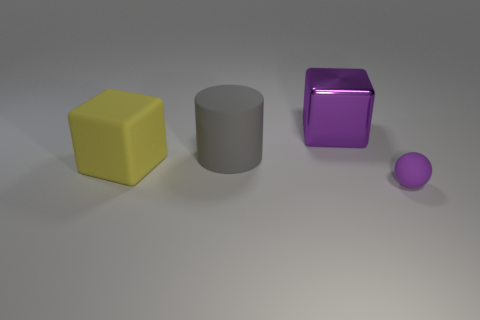Add 1 large green metallic cylinders. How many objects exist? 5 Subtract all spheres. How many objects are left? 3 Add 3 purple cubes. How many purple cubes are left? 4 Add 1 gray rubber objects. How many gray rubber objects exist? 2 Subtract 0 gray spheres. How many objects are left? 4 Subtract all big rubber things. Subtract all small purple matte things. How many objects are left? 1 